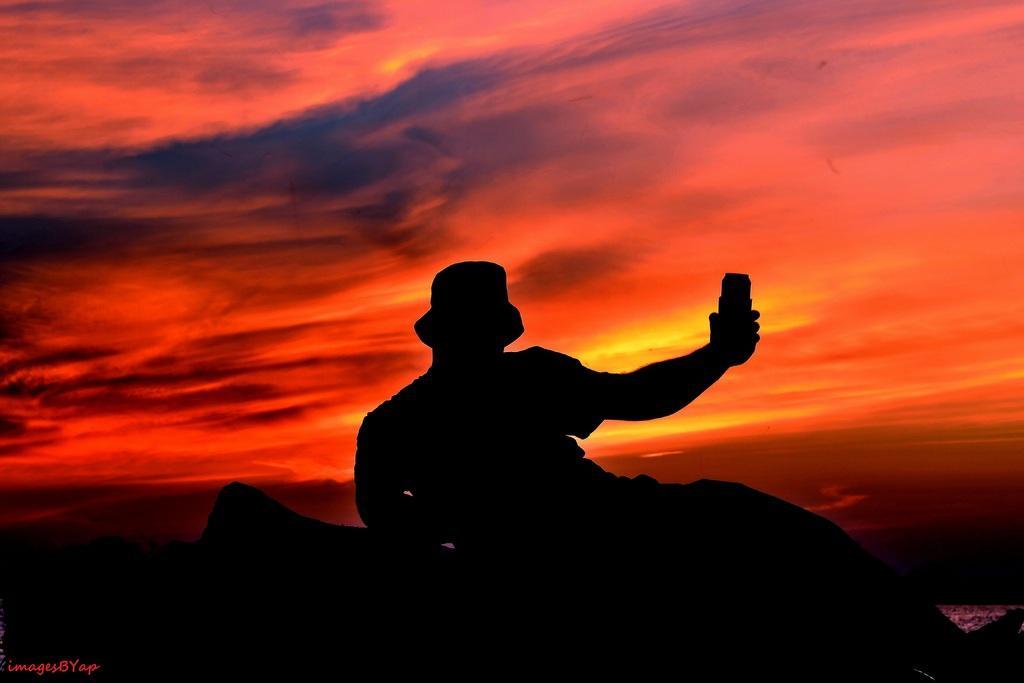In one or two sentences, can you explain what this image depicts? In this image, we can see depiction of a person. There is a sky at the top of the image. 